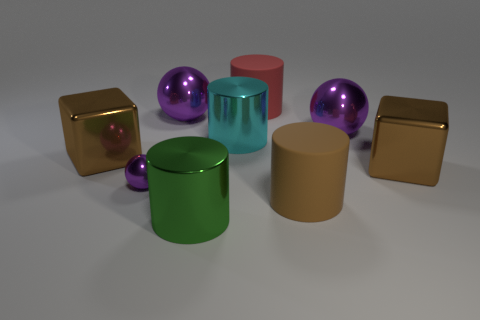Add 1 big cyan metal things. How many objects exist? 10 Subtract all cylinders. How many objects are left? 5 Add 3 tiny spheres. How many tiny spheres exist? 4 Subtract 0 gray spheres. How many objects are left? 9 Subtract all cyan cylinders. Subtract all red rubber objects. How many objects are left? 7 Add 9 large brown matte objects. How many large brown matte objects are left? 10 